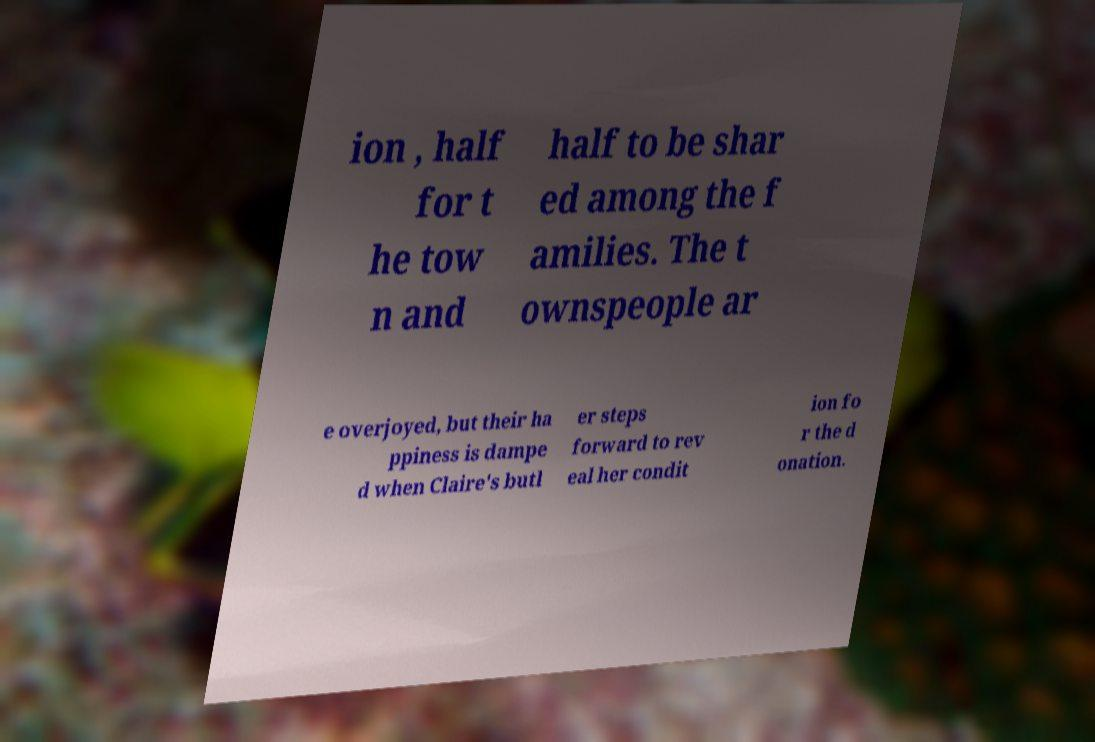Please identify and transcribe the text found in this image. ion , half for t he tow n and half to be shar ed among the f amilies. The t ownspeople ar e overjoyed, but their ha ppiness is dampe d when Claire's butl er steps forward to rev eal her condit ion fo r the d onation. 